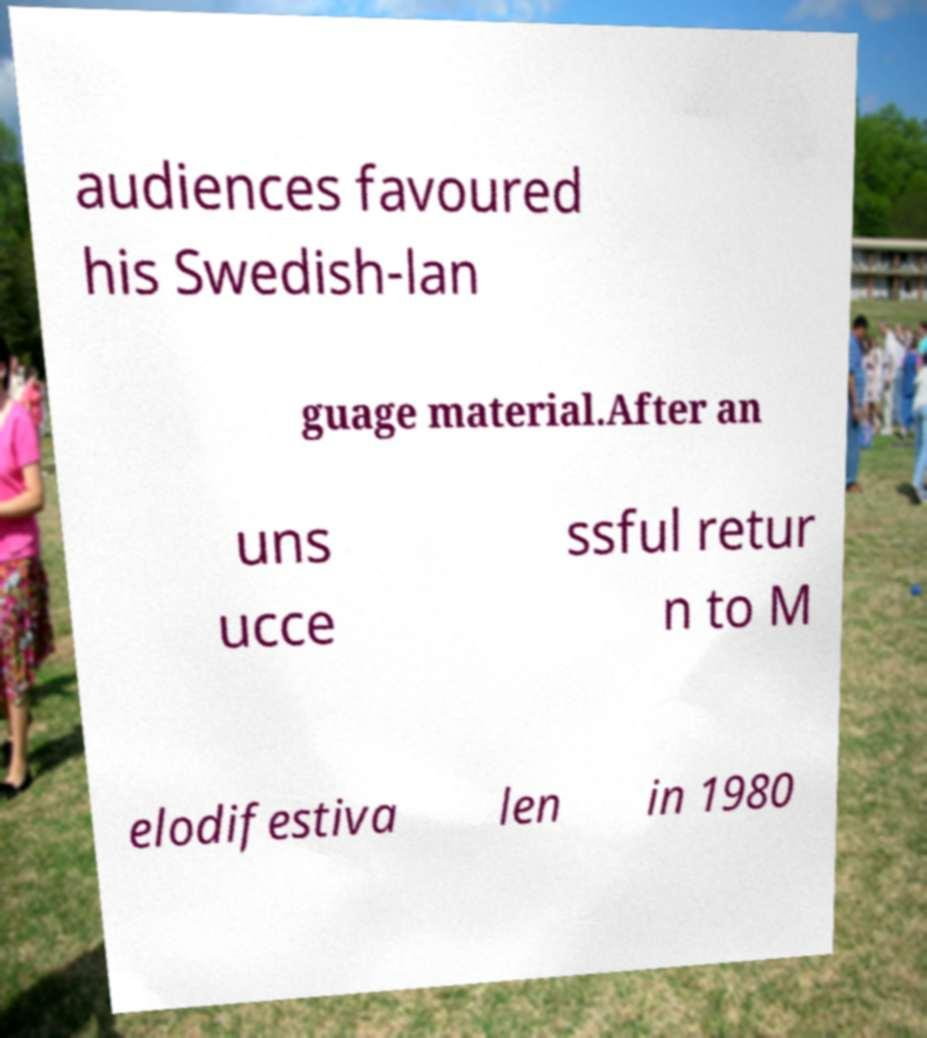Could you extract and type out the text from this image? audiences favoured his Swedish-lan guage material.After an uns ucce ssful retur n to M elodifestiva len in 1980 